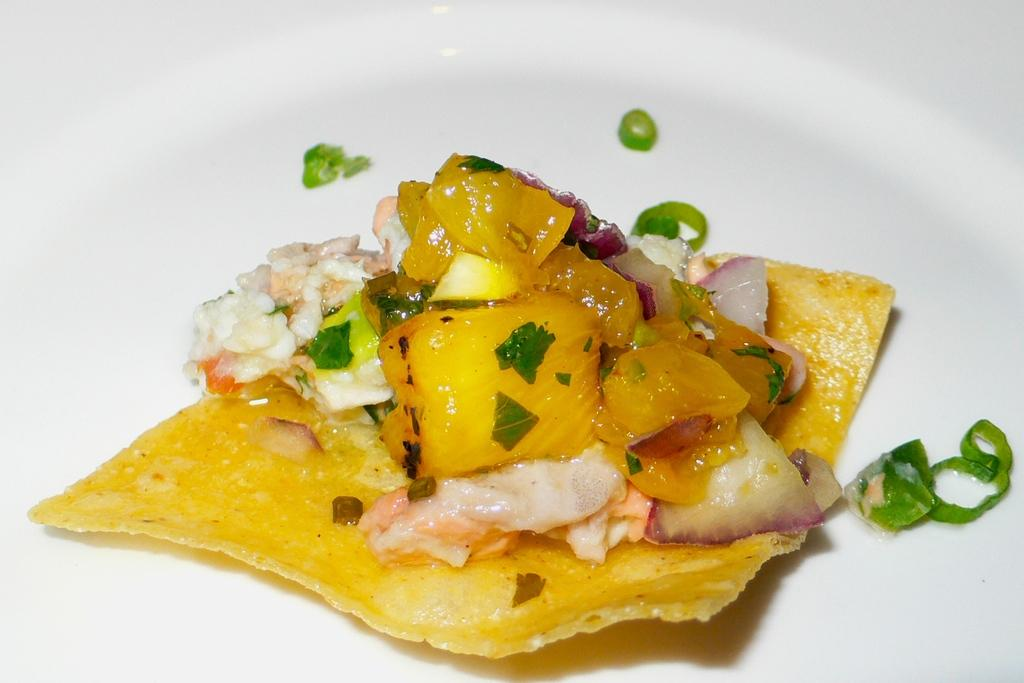What types of items can be seen in the image? There are food items in the image. What is the color of the object on which the food items are placed? The food items are on a white object. What chess pieces are visible on the back of the white object in the image? There are no chess pieces or any reference to a "back" of the white object in the image; it only features food items. 